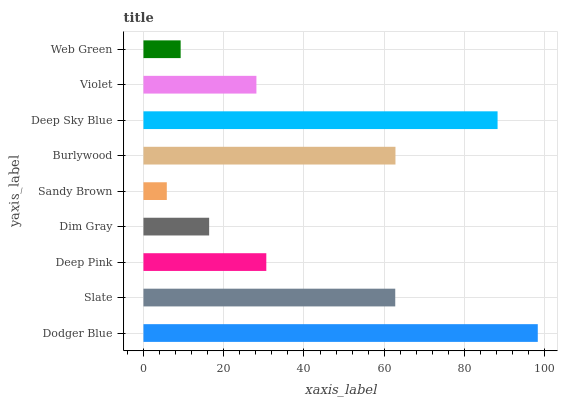Is Sandy Brown the minimum?
Answer yes or no. Yes. Is Dodger Blue the maximum?
Answer yes or no. Yes. Is Slate the minimum?
Answer yes or no. No. Is Slate the maximum?
Answer yes or no. No. Is Dodger Blue greater than Slate?
Answer yes or no. Yes. Is Slate less than Dodger Blue?
Answer yes or no. Yes. Is Slate greater than Dodger Blue?
Answer yes or no. No. Is Dodger Blue less than Slate?
Answer yes or no. No. Is Deep Pink the high median?
Answer yes or no. Yes. Is Deep Pink the low median?
Answer yes or no. Yes. Is Sandy Brown the high median?
Answer yes or no. No. Is Dodger Blue the low median?
Answer yes or no. No. 